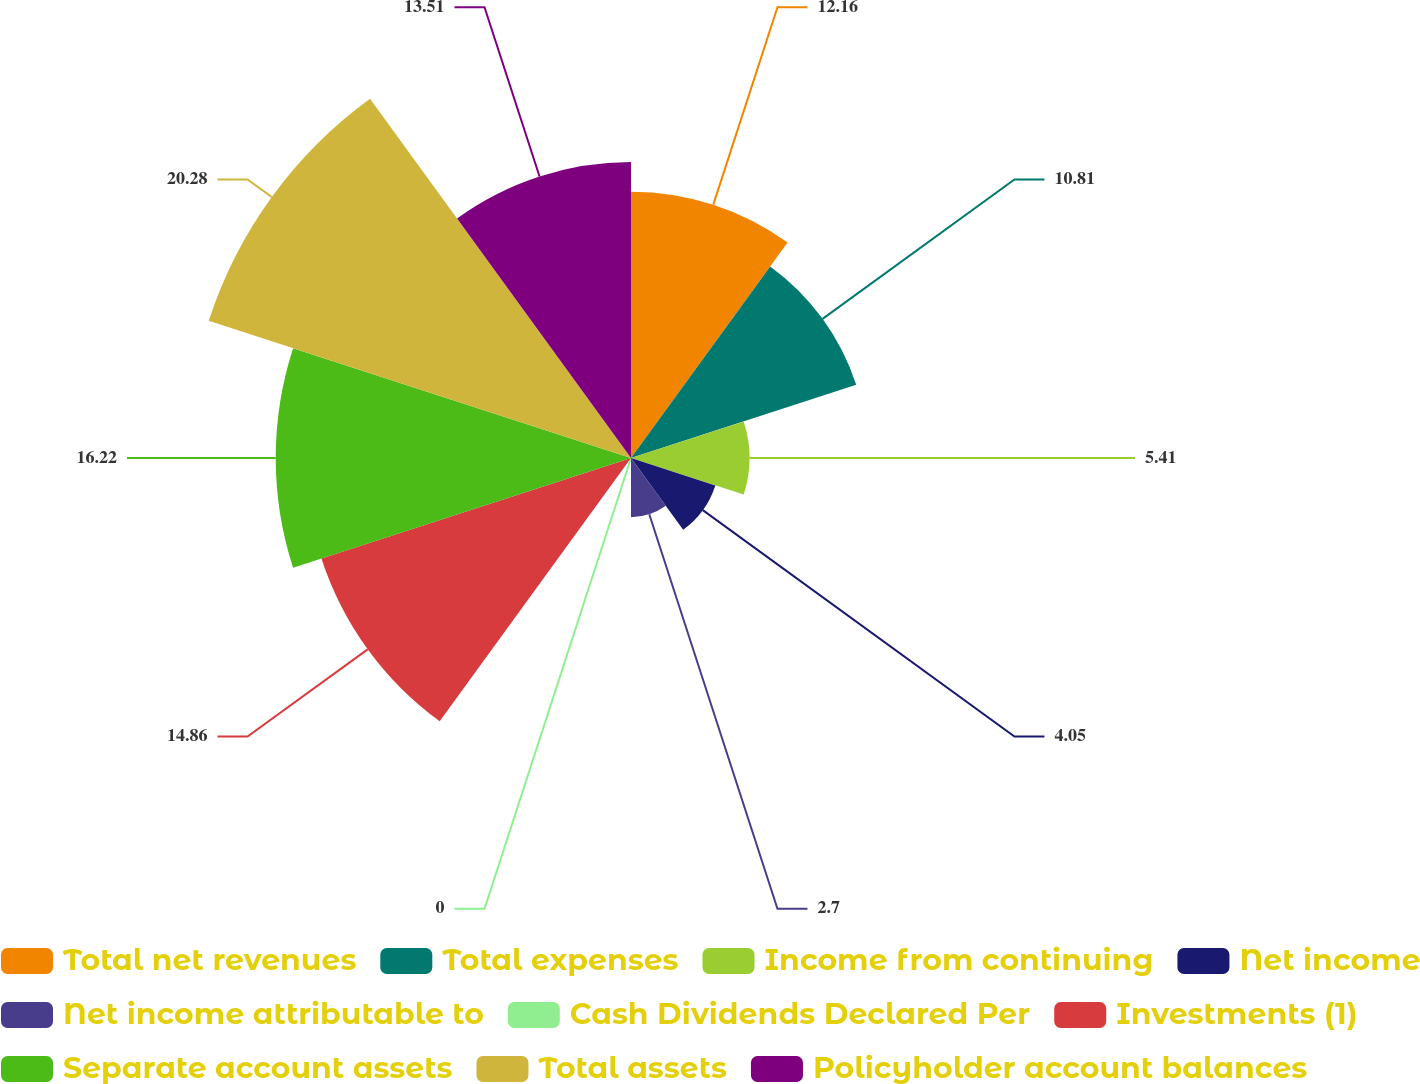Convert chart. <chart><loc_0><loc_0><loc_500><loc_500><pie_chart><fcel>Total net revenues<fcel>Total expenses<fcel>Income from continuing<fcel>Net income<fcel>Net income attributable to<fcel>Cash Dividends Declared Per<fcel>Investments (1)<fcel>Separate account assets<fcel>Total assets<fcel>Policyholder account balances<nl><fcel>12.16%<fcel>10.81%<fcel>5.41%<fcel>4.05%<fcel>2.7%<fcel>0.0%<fcel>14.86%<fcel>16.22%<fcel>20.27%<fcel>13.51%<nl></chart> 